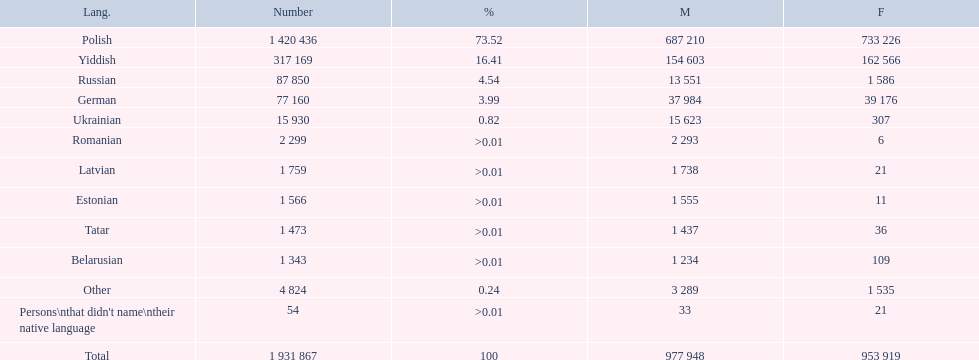What are all the languages? Polish, Yiddish, Russian, German, Ukrainian, Romanian, Latvian, Estonian, Tatar, Belarusian, Other. Which only have percentages >0.01? Romanian, Latvian, Estonian, Tatar, Belarusian. Of these, which has the greatest number of speakers? Romanian. 